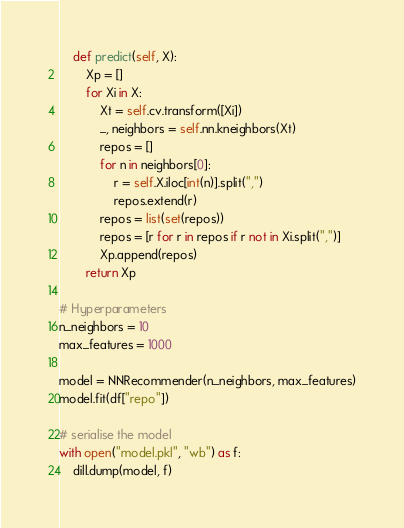Convert code to text. <code><loc_0><loc_0><loc_500><loc_500><_Python_>    def predict(self, X):
        Xp = []
        for Xi in X:
            Xt = self.cv.transform([Xi])
            _, neighbors = self.nn.kneighbors(Xt)
            repos = []
            for n in neighbors[0]:
                r = self.X.iloc[int(n)].split(",")
                repos.extend(r)
            repos = list(set(repos))
            repos = [r for r in repos if r not in Xi.split(",")]
            Xp.append(repos)
        return Xp

# Hyperparameters
n_neighbors = 10
max_features = 1000

model = NNRecommender(n_neighbors, max_features)
model.fit(df["repo"])

# serialise the model
with open("model.pkl", "wb") as f:
    dill.dump(model, f)
</code> 